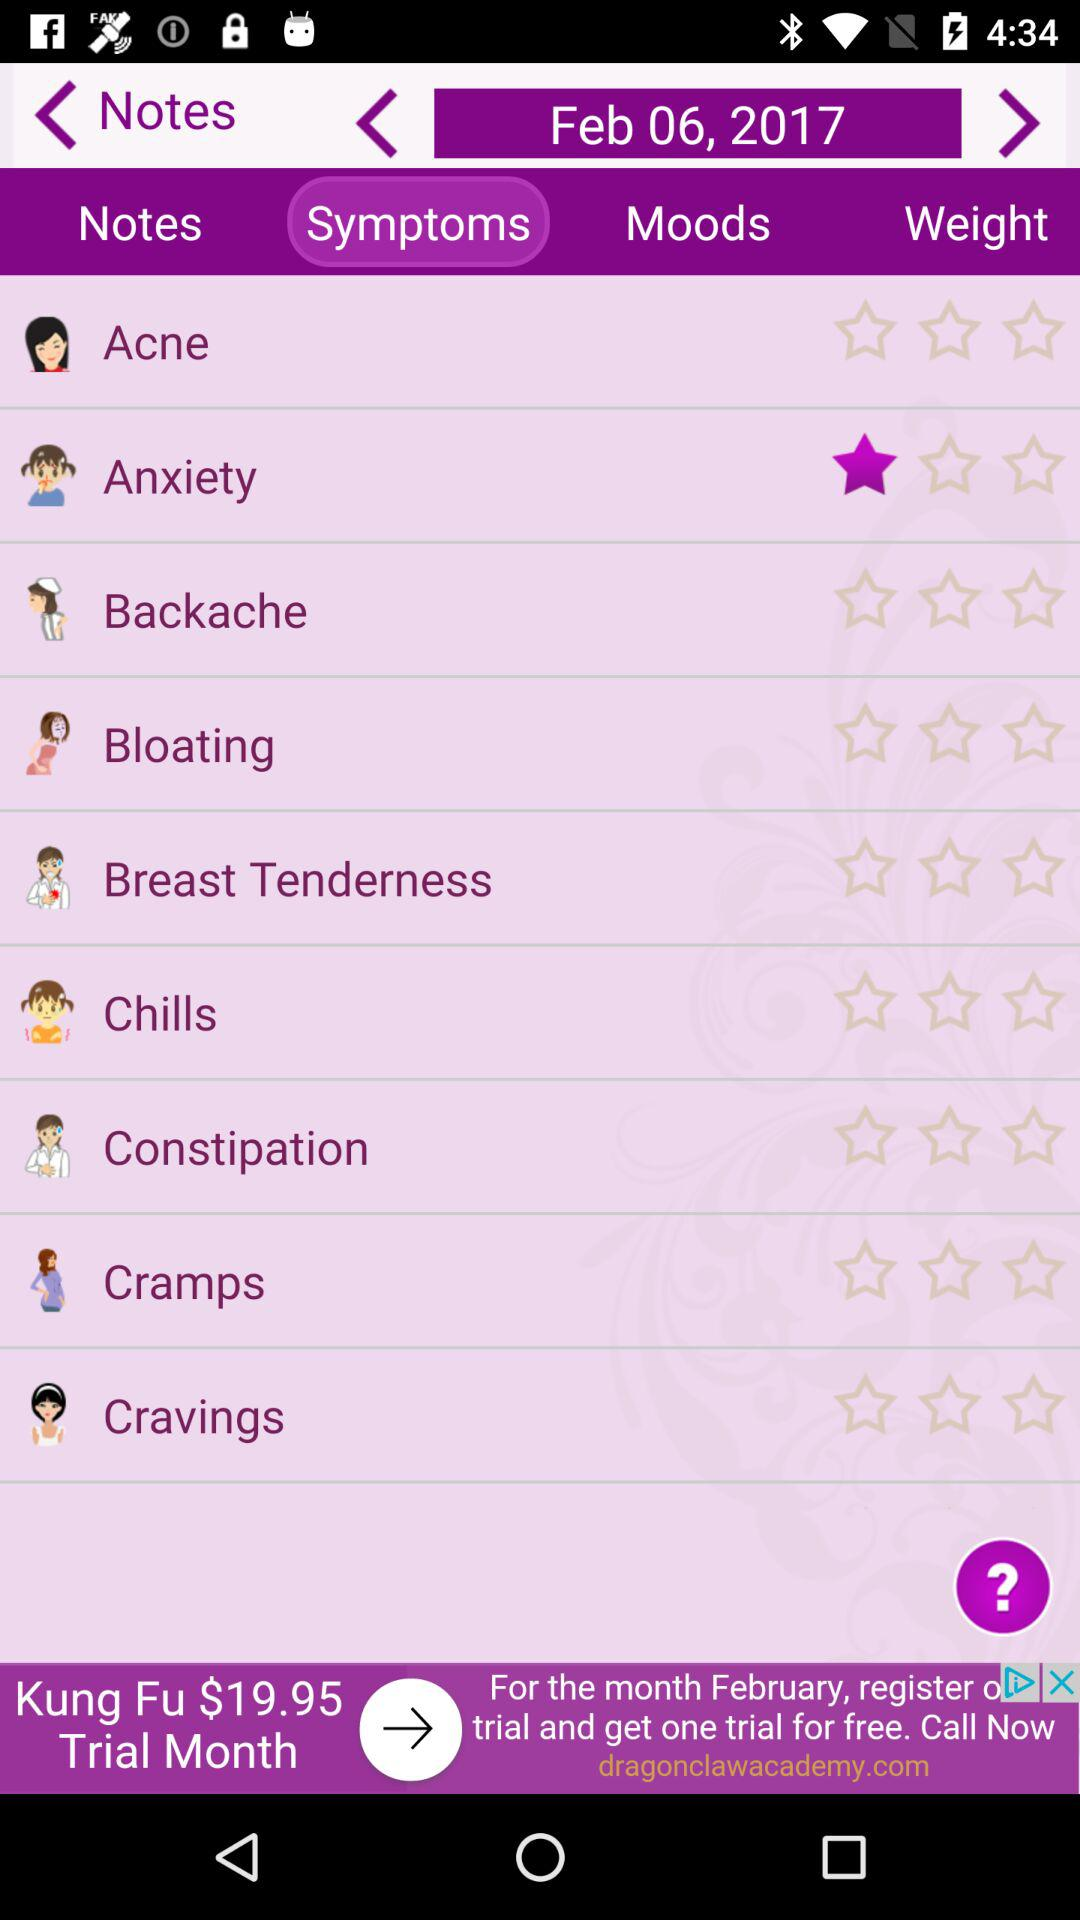What is the date? The date is February 6, 2017. 